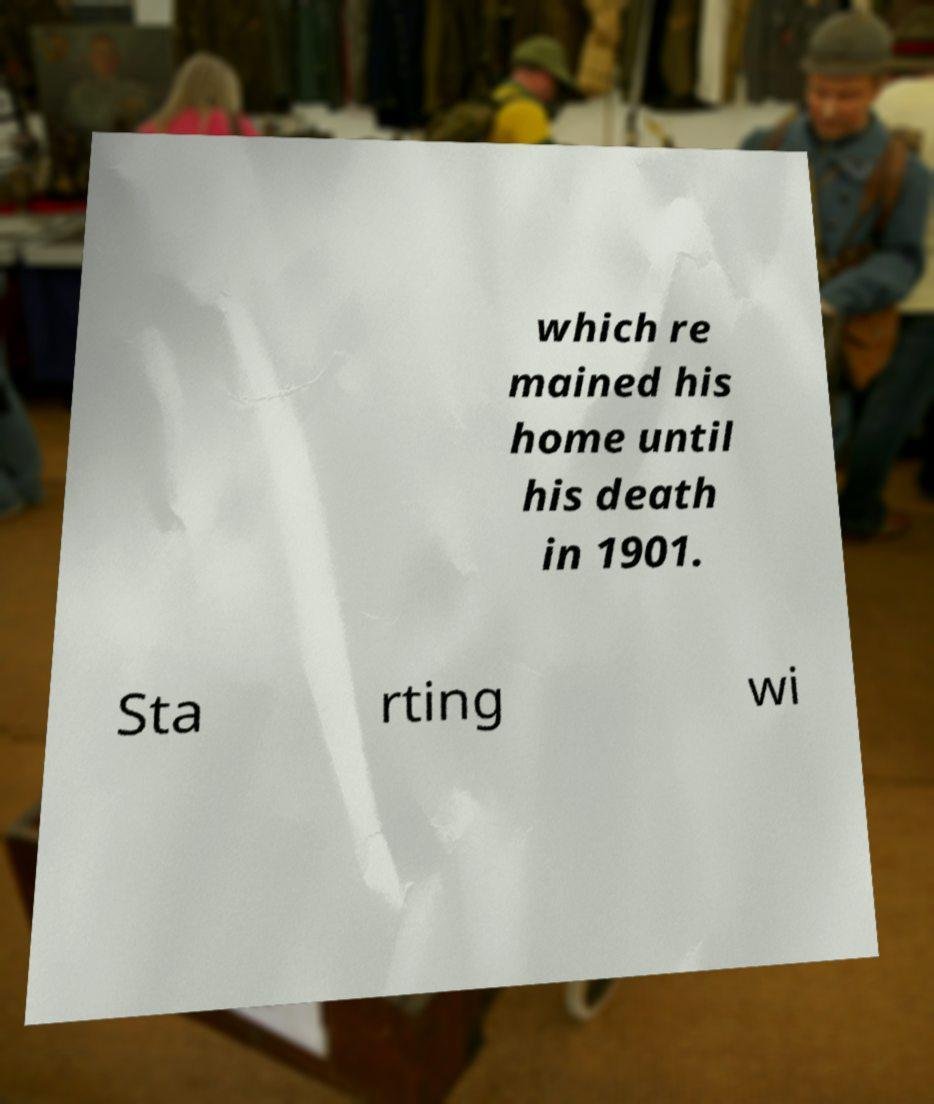Please identify and transcribe the text found in this image. which re mained his home until his death in 1901. Sta rting wi 